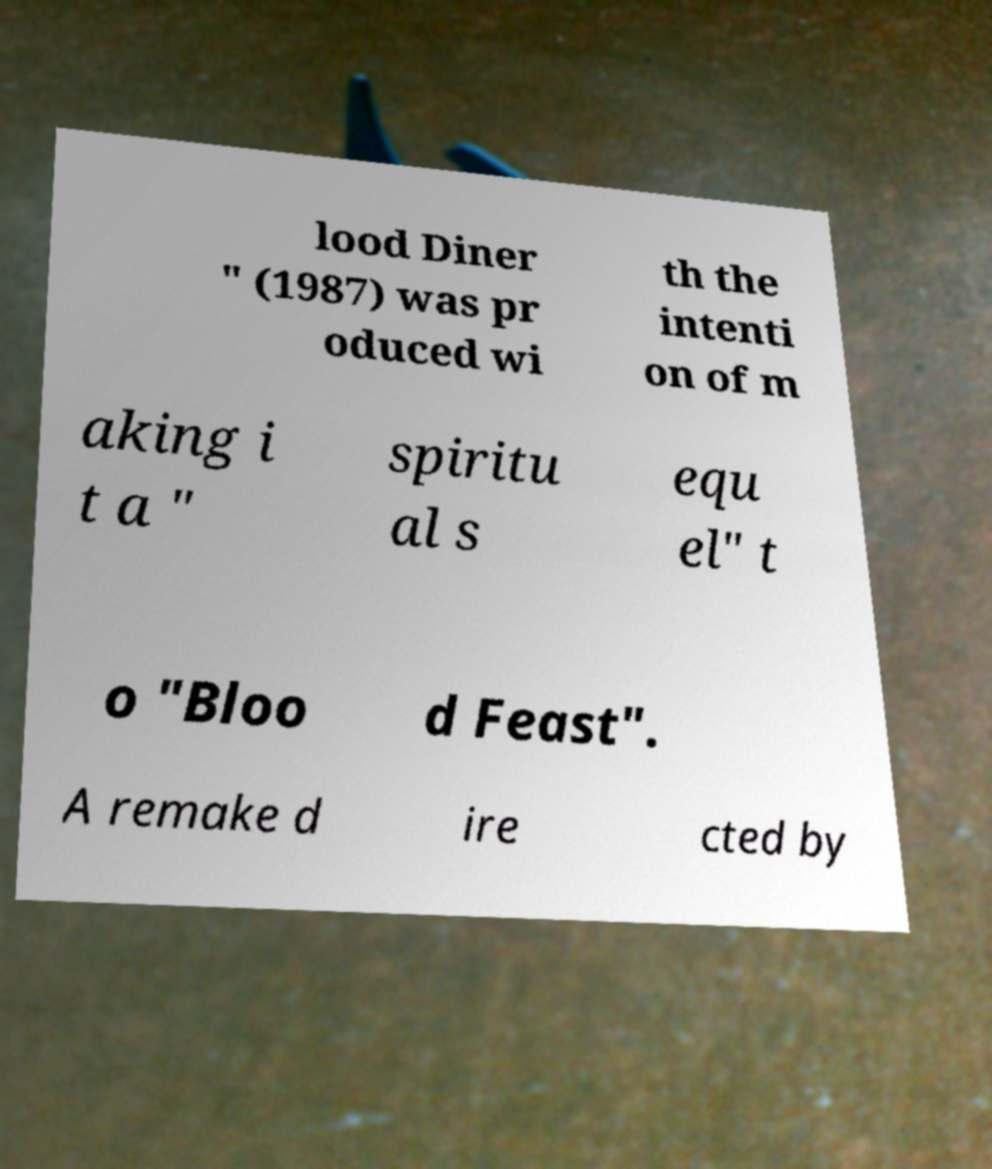Could you extract and type out the text from this image? lood Diner " (1987) was pr oduced wi th the intenti on of m aking i t a " spiritu al s equ el" t o "Bloo d Feast". A remake d ire cted by 